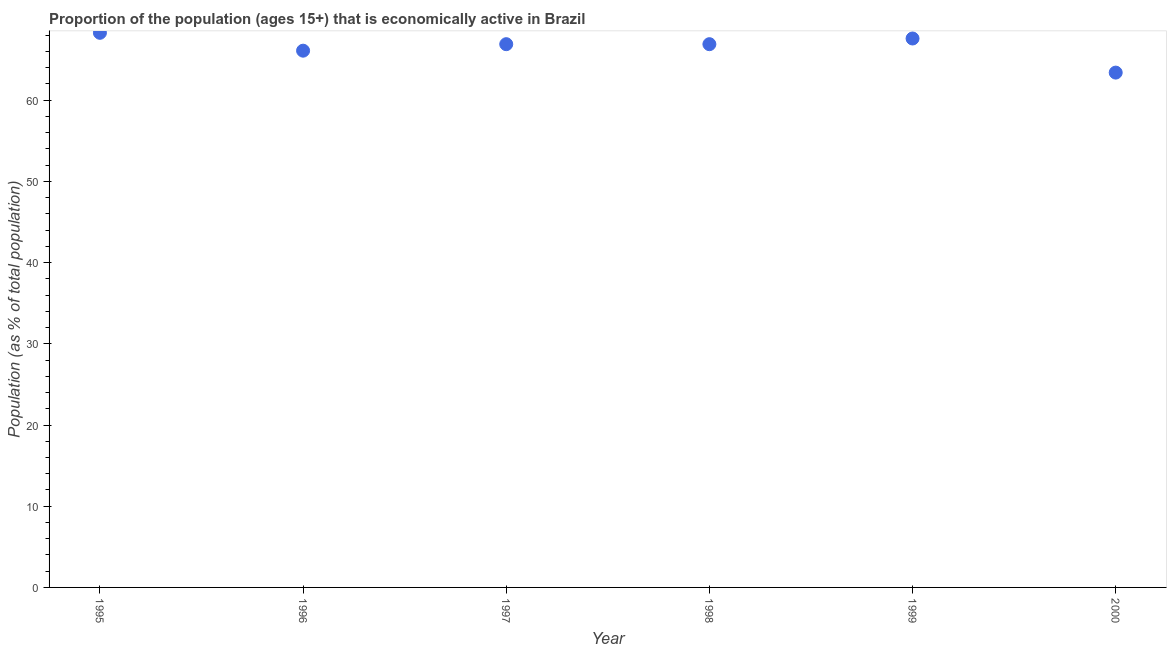What is the percentage of economically active population in 1998?
Give a very brief answer. 66.9. Across all years, what is the maximum percentage of economically active population?
Your response must be concise. 68.3. Across all years, what is the minimum percentage of economically active population?
Provide a succinct answer. 63.4. In which year was the percentage of economically active population maximum?
Keep it short and to the point. 1995. In which year was the percentage of economically active population minimum?
Give a very brief answer. 2000. What is the sum of the percentage of economically active population?
Provide a succinct answer. 399.2. What is the difference between the percentage of economically active population in 1995 and 1998?
Offer a very short reply. 1.4. What is the average percentage of economically active population per year?
Give a very brief answer. 66.53. What is the median percentage of economically active population?
Your answer should be very brief. 66.9. Do a majority of the years between 1998 and 1995 (inclusive) have percentage of economically active population greater than 32 %?
Give a very brief answer. Yes. What is the ratio of the percentage of economically active population in 1996 to that in 1997?
Ensure brevity in your answer.  0.99. Is the percentage of economically active population in 1995 less than that in 1997?
Make the answer very short. No. Is the difference between the percentage of economically active population in 1999 and 2000 greater than the difference between any two years?
Offer a terse response. No. What is the difference between the highest and the second highest percentage of economically active population?
Offer a very short reply. 0.7. Is the sum of the percentage of economically active population in 1996 and 1999 greater than the maximum percentage of economically active population across all years?
Offer a terse response. Yes. What is the difference between the highest and the lowest percentage of economically active population?
Your response must be concise. 4.9. In how many years, is the percentage of economically active population greater than the average percentage of economically active population taken over all years?
Keep it short and to the point. 4. Does the percentage of economically active population monotonically increase over the years?
Offer a very short reply. No. What is the title of the graph?
Ensure brevity in your answer.  Proportion of the population (ages 15+) that is economically active in Brazil. What is the label or title of the Y-axis?
Your answer should be compact. Population (as % of total population). What is the Population (as % of total population) in 1995?
Offer a terse response. 68.3. What is the Population (as % of total population) in 1996?
Ensure brevity in your answer.  66.1. What is the Population (as % of total population) in 1997?
Provide a short and direct response. 66.9. What is the Population (as % of total population) in 1998?
Keep it short and to the point. 66.9. What is the Population (as % of total population) in 1999?
Give a very brief answer. 67.6. What is the Population (as % of total population) in 2000?
Give a very brief answer. 63.4. What is the difference between the Population (as % of total population) in 1995 and 1996?
Your answer should be very brief. 2.2. What is the difference between the Population (as % of total population) in 1995 and 1998?
Make the answer very short. 1.4. What is the difference between the Population (as % of total population) in 1995 and 2000?
Provide a short and direct response. 4.9. What is the difference between the Population (as % of total population) in 1996 and 2000?
Give a very brief answer. 2.7. What is the difference between the Population (as % of total population) in 1997 and 1999?
Provide a succinct answer. -0.7. What is the difference between the Population (as % of total population) in 1997 and 2000?
Your answer should be compact. 3.5. What is the difference between the Population (as % of total population) in 1998 and 1999?
Give a very brief answer. -0.7. What is the difference between the Population (as % of total population) in 1998 and 2000?
Give a very brief answer. 3.5. What is the ratio of the Population (as % of total population) in 1995 to that in 1996?
Your response must be concise. 1.03. What is the ratio of the Population (as % of total population) in 1995 to that in 1999?
Give a very brief answer. 1.01. What is the ratio of the Population (as % of total population) in 1995 to that in 2000?
Keep it short and to the point. 1.08. What is the ratio of the Population (as % of total population) in 1996 to that in 1997?
Keep it short and to the point. 0.99. What is the ratio of the Population (as % of total population) in 1996 to that in 1999?
Your answer should be compact. 0.98. What is the ratio of the Population (as % of total population) in 1996 to that in 2000?
Keep it short and to the point. 1.04. What is the ratio of the Population (as % of total population) in 1997 to that in 2000?
Provide a succinct answer. 1.05. What is the ratio of the Population (as % of total population) in 1998 to that in 2000?
Provide a short and direct response. 1.05. What is the ratio of the Population (as % of total population) in 1999 to that in 2000?
Your answer should be compact. 1.07. 